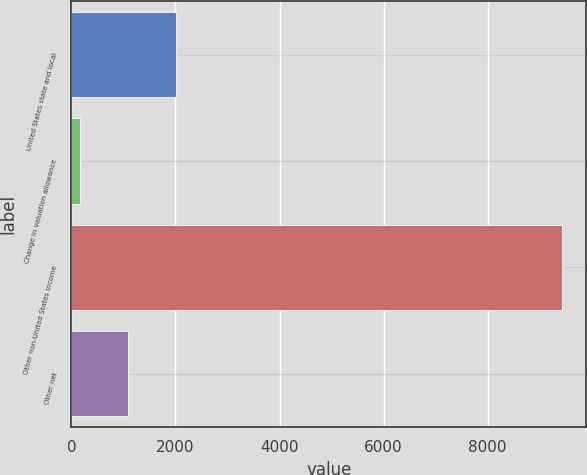<chart> <loc_0><loc_0><loc_500><loc_500><bar_chart><fcel>United States state and local<fcel>Change in valuation allowance<fcel>Other non-United States income<fcel>Other net<nl><fcel>2013.6<fcel>160<fcel>9428<fcel>1086.8<nl></chart> 